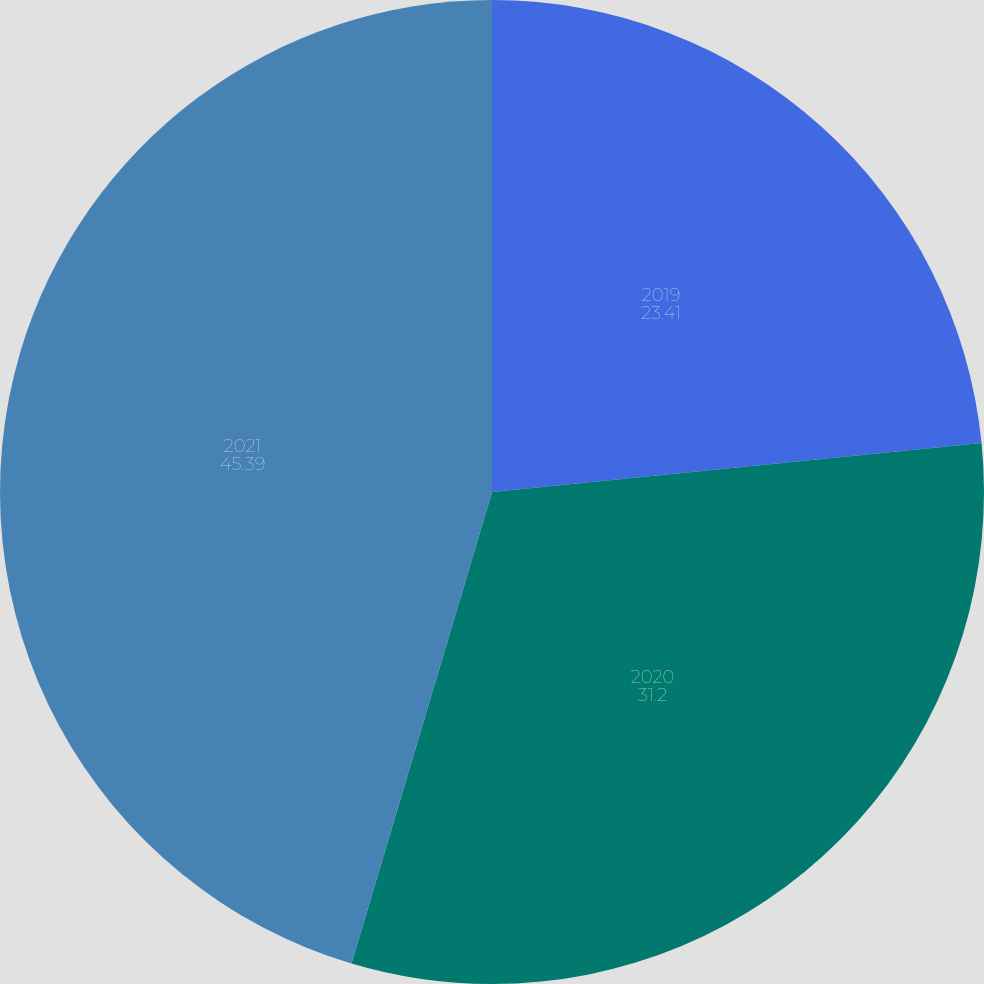Convert chart. <chart><loc_0><loc_0><loc_500><loc_500><pie_chart><fcel>2019<fcel>2020<fcel>2021<nl><fcel>23.41%<fcel>31.2%<fcel>45.39%<nl></chart> 